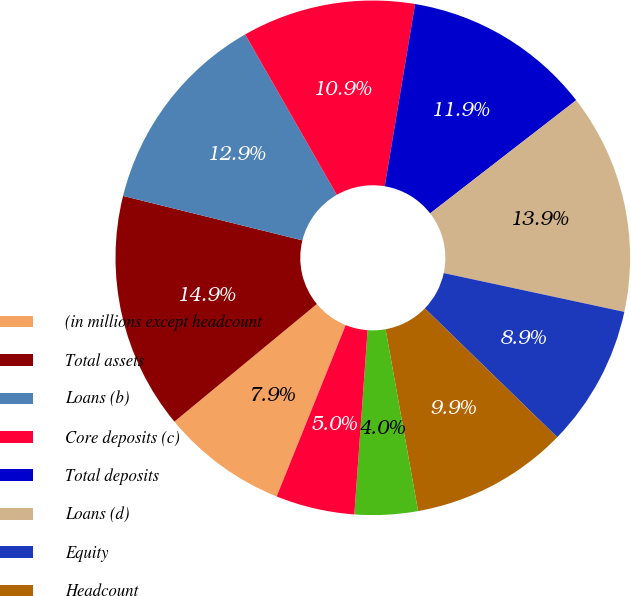Convert chart. <chart><loc_0><loc_0><loc_500><loc_500><pie_chart><fcel>(in millions except headcount<fcel>Total assets<fcel>Loans (b)<fcel>Core deposits (c)<fcel>Total deposits<fcel>Loans (d)<fcel>Equity<fcel>Headcount<fcel>Net charge-offs (e)<fcel>Nonperforming loans (f)<nl><fcel>7.92%<fcel>14.85%<fcel>12.87%<fcel>10.89%<fcel>11.88%<fcel>13.86%<fcel>8.91%<fcel>9.9%<fcel>3.96%<fcel>4.95%<nl></chart> 